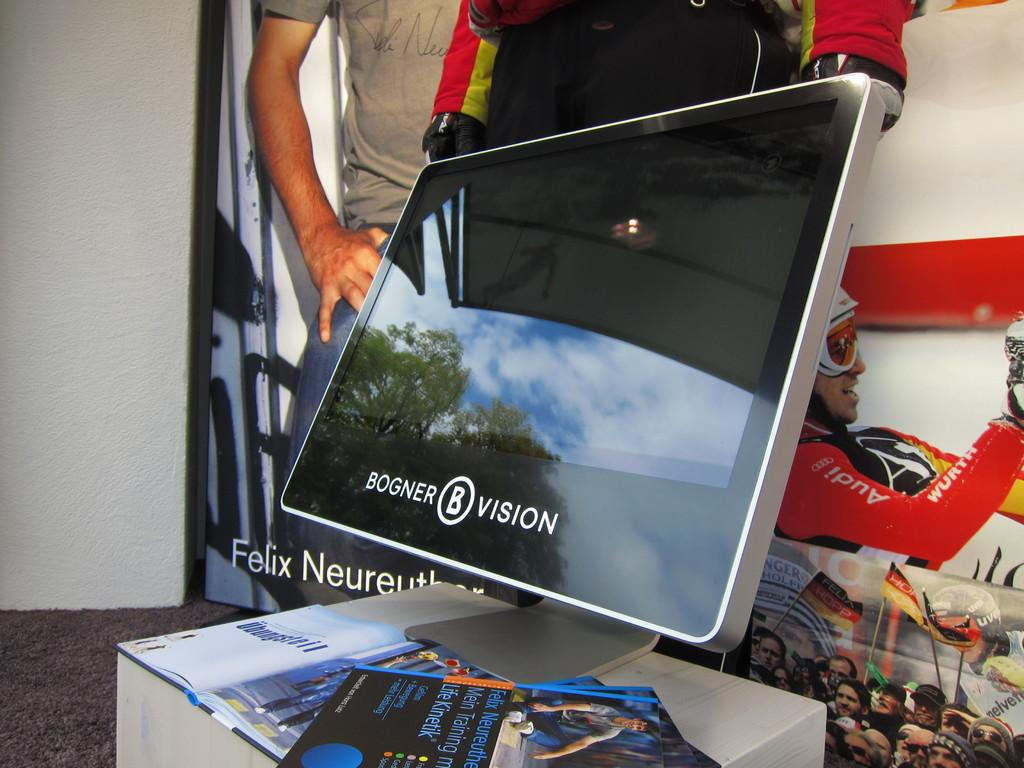What is the main object on the table in the image? There is a computer screen on the table in the image. What else can be seen on the table? There are books beside the computer screen. What is in the background of the image? There is a banner in the background of the image. Can you describe the banner? The banner has a person depicted on it. What type of trouble is the person on the banner experiencing during their voyage? There is no indication of a voyage or trouble in the image, as it only features a computer screen, books, and a banner with a person depicted on it. 